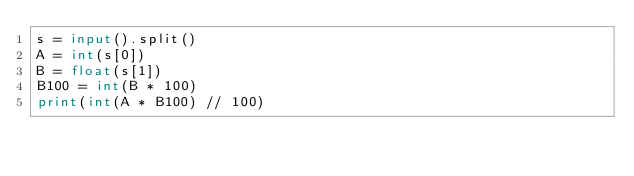<code> <loc_0><loc_0><loc_500><loc_500><_Python_>s = input().split()
A = int(s[0])
B = float(s[1])
B100 = int(B * 100)
print(int(A * B100) // 100)</code> 